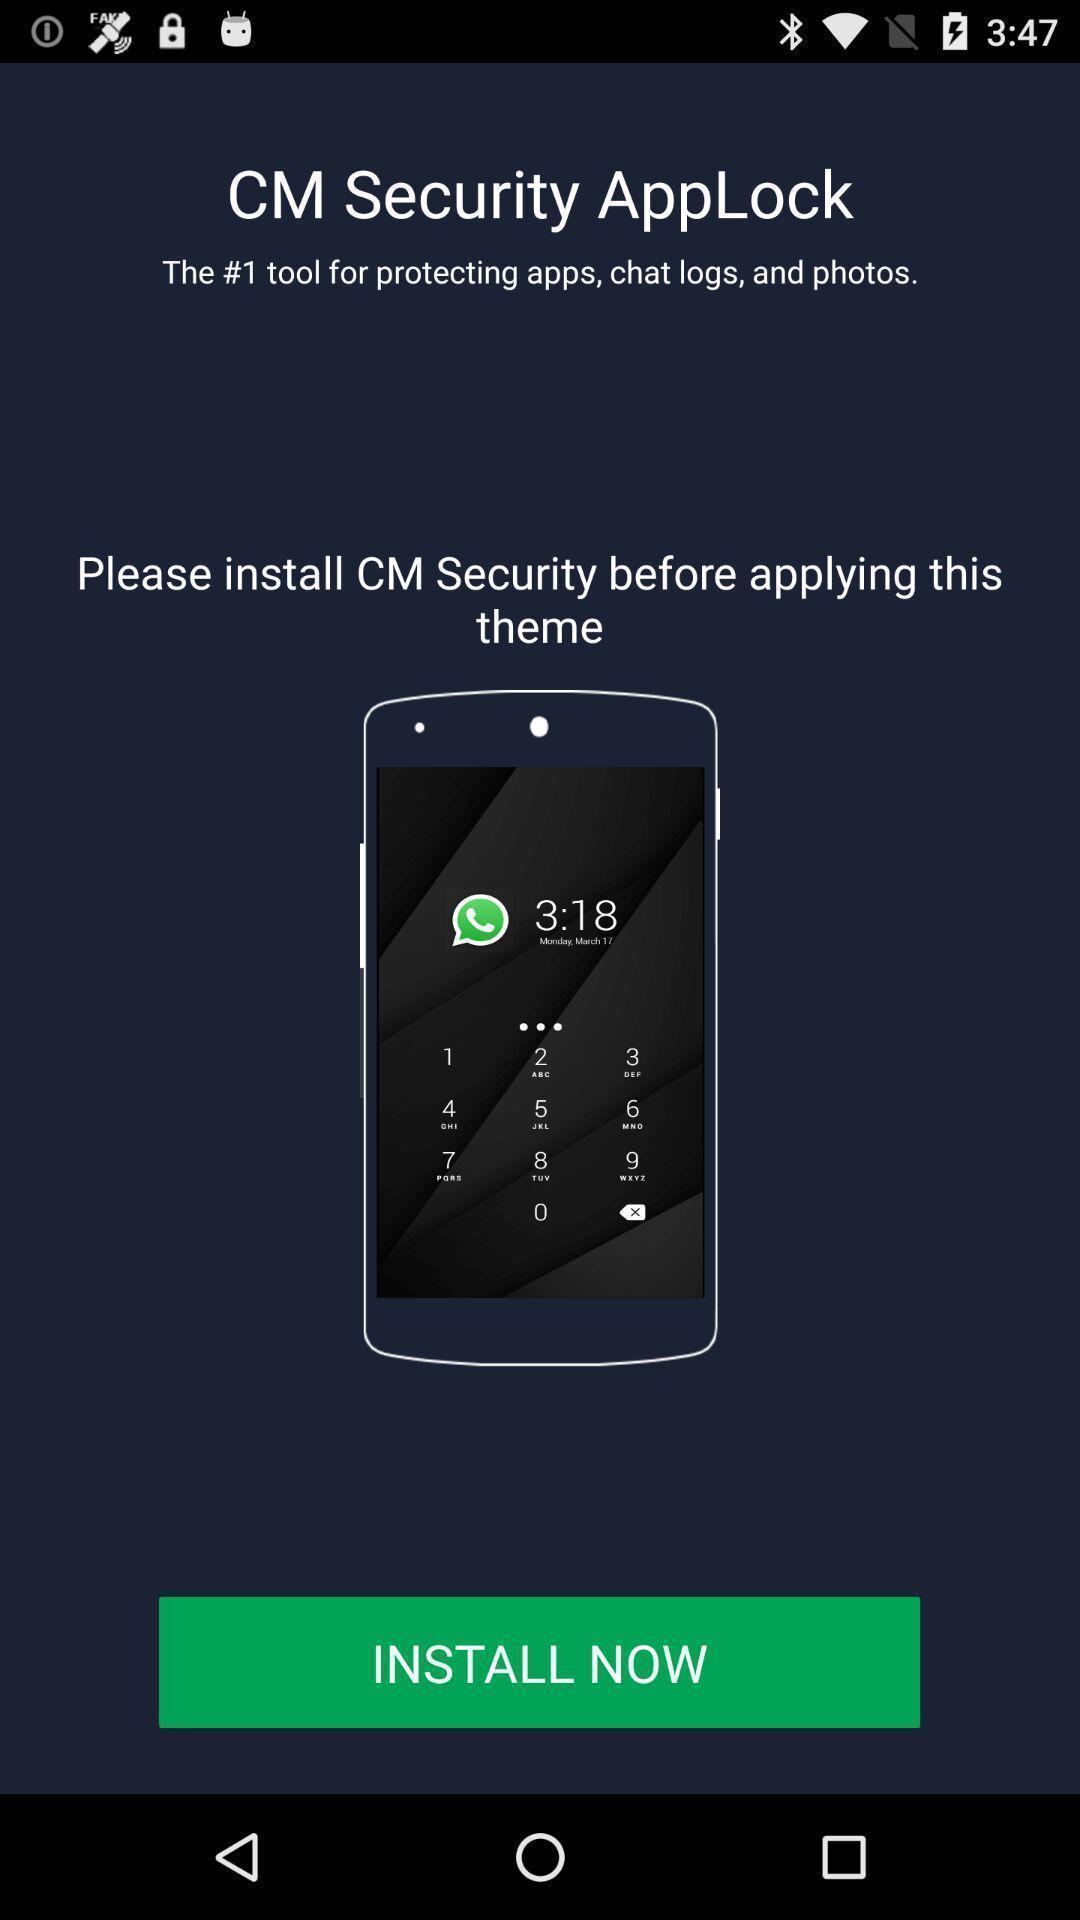Summarize the information in this screenshot. Page displaying information about security app. 